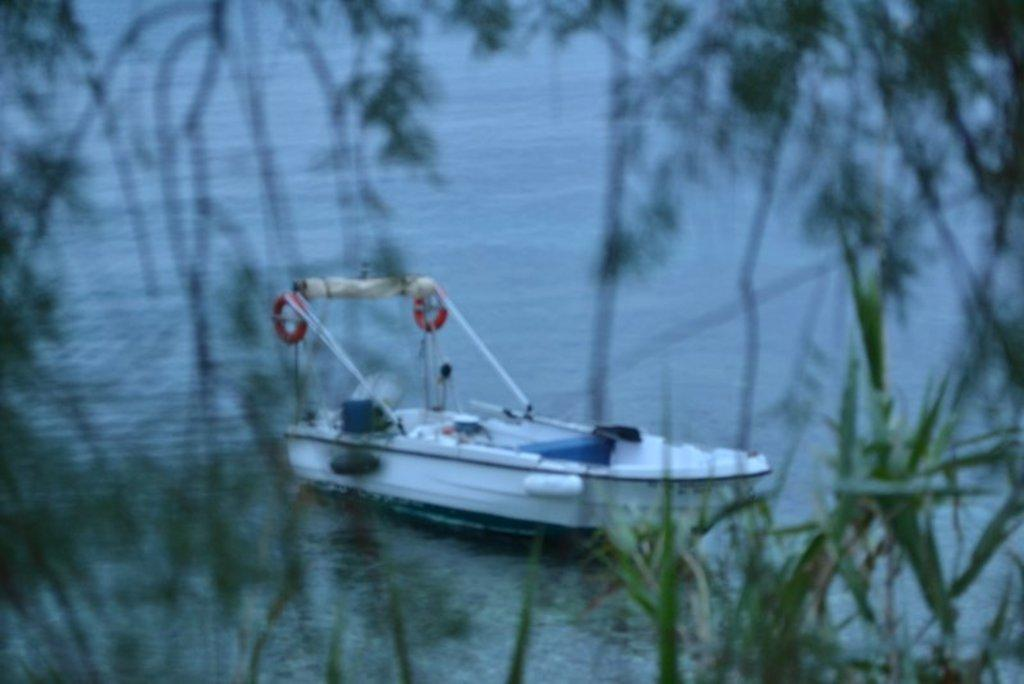What is the main subject of the image? The main subject of the image is a boat. Where is the boat located? The boat is on the water. What is the color of the boat? The boat is white in color. What can be seen in the background of the image? There are trees visible in the image. What type of lock can be seen on the boat in the image? There is no lock present on the boat in the image. 